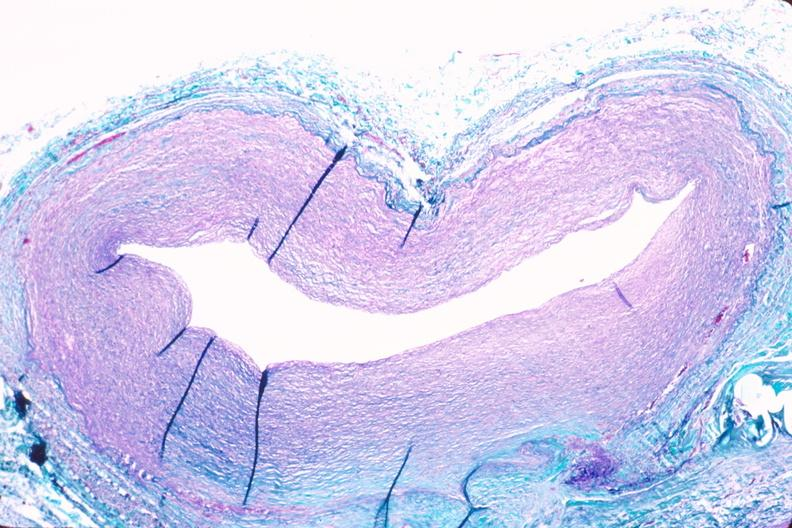s sacrococcygeal teratoma present?
Answer the question using a single word or phrase. No 